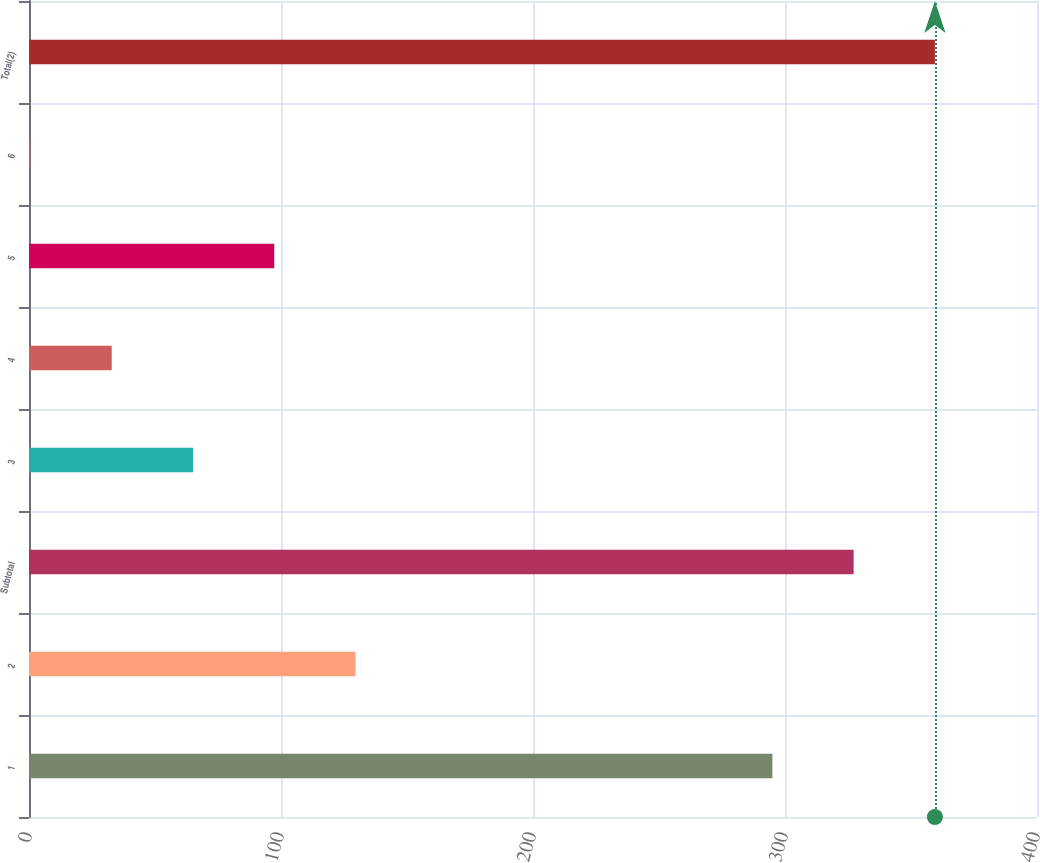<chart> <loc_0><loc_0><loc_500><loc_500><bar_chart><fcel>1<fcel>2<fcel>Subtotal<fcel>3<fcel>4<fcel>5<fcel>6<fcel>Total(2)<nl><fcel>295<fcel>129.55<fcel>327.24<fcel>65.07<fcel>32.83<fcel>97.31<fcel>0.59<fcel>359.48<nl></chart> 